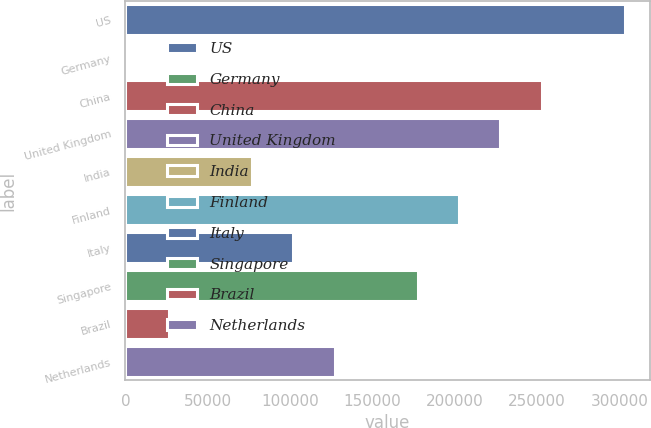Convert chart. <chart><loc_0><loc_0><loc_500><loc_500><bar_chart><fcel>US<fcel>Germany<fcel>China<fcel>United Kingdom<fcel>India<fcel>Finland<fcel>Italy<fcel>Singapore<fcel>Brazil<fcel>Netherlands<nl><fcel>303394<fcel>1187<fcel>253026<fcel>227842<fcel>76738.7<fcel>202658<fcel>101923<fcel>177474<fcel>26370.9<fcel>127106<nl></chart> 